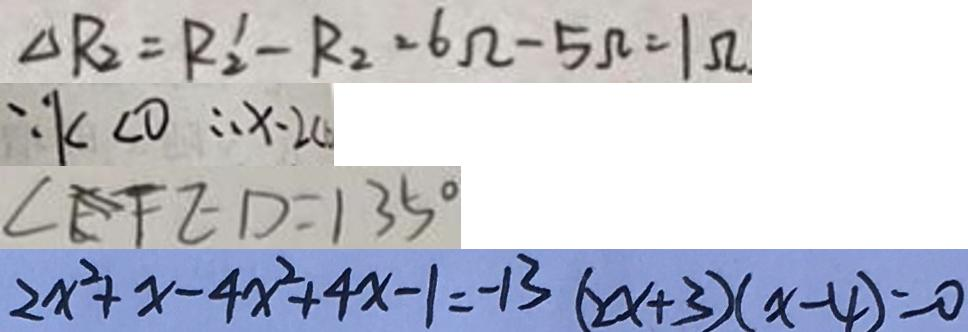<formula> <loc_0><loc_0><loc_500><loc_500>\Delta R _ { 2 } = R _ { 2 } ^ { \prime } - R _ { 2 } = 6 \Omega - 5 \Omega = 1 \Omega _ { \cdot } 
 \because k < 0 \therefore x - 2 < 
 \angle E F E D = 1 3 5 ^ { \circ } 
 2 x ^ { 2 } + x - 4 x ^ { 2 } + 4 x - 1 = - 1 3 ( 2 x + 3 ) ( x - 4 ) = 0</formula> 